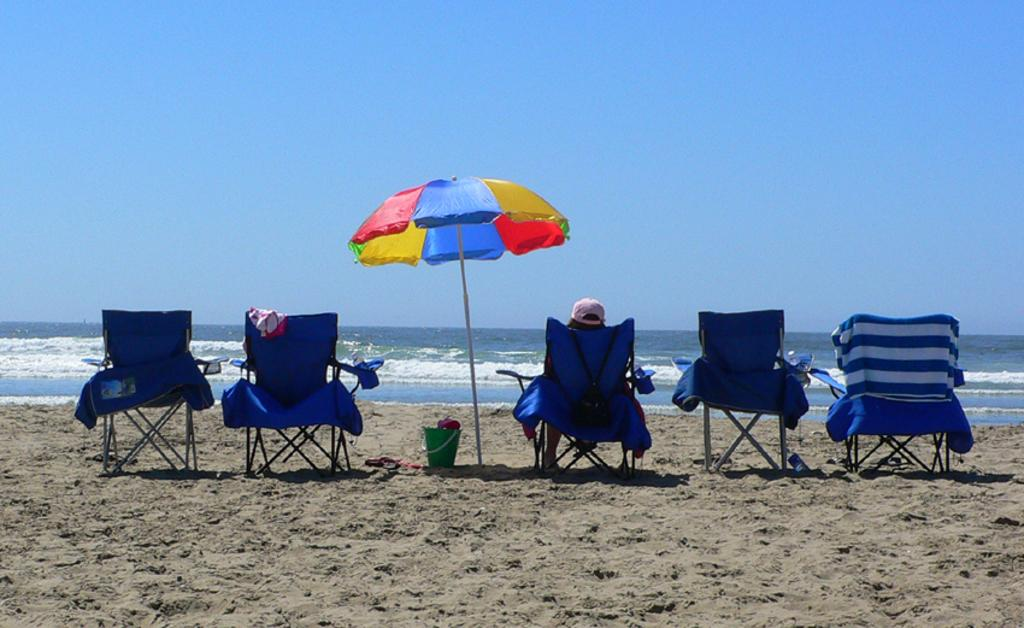How many chairs are in the image? There are five chairs in the image. What additional object can be seen in the image? There is an umbrella in the image. What is located on the sand in the image? There is a bucket on the sand in the image. Can you describe the person in the image? A person is sitting on one of the chairs. What can be seen in the background of the image? There is water and the sky visible in the background of the image. How many kittens are rubbing their feet on the chairs in the image? There are no kittens present in the image, and therefore no such activity can be observed. 